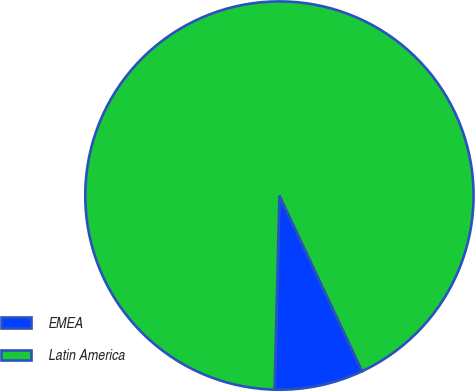Convert chart. <chart><loc_0><loc_0><loc_500><loc_500><pie_chart><fcel>EMEA<fcel>Latin America<nl><fcel>7.4%<fcel>92.6%<nl></chart> 